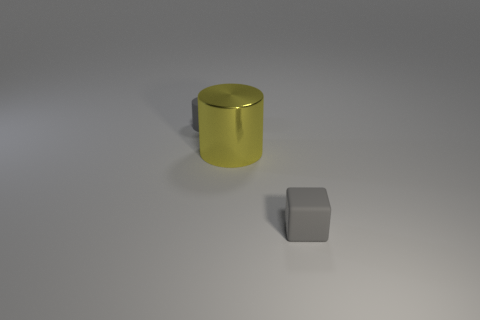Add 3 gray cylinders. How many objects exist? 6 Subtract all cylinders. How many objects are left? 1 Add 1 small cylinders. How many small cylinders are left? 2 Add 2 brown cubes. How many brown cubes exist? 2 Subtract 1 yellow cylinders. How many objects are left? 2 Subtract all small objects. Subtract all yellow matte cubes. How many objects are left? 1 